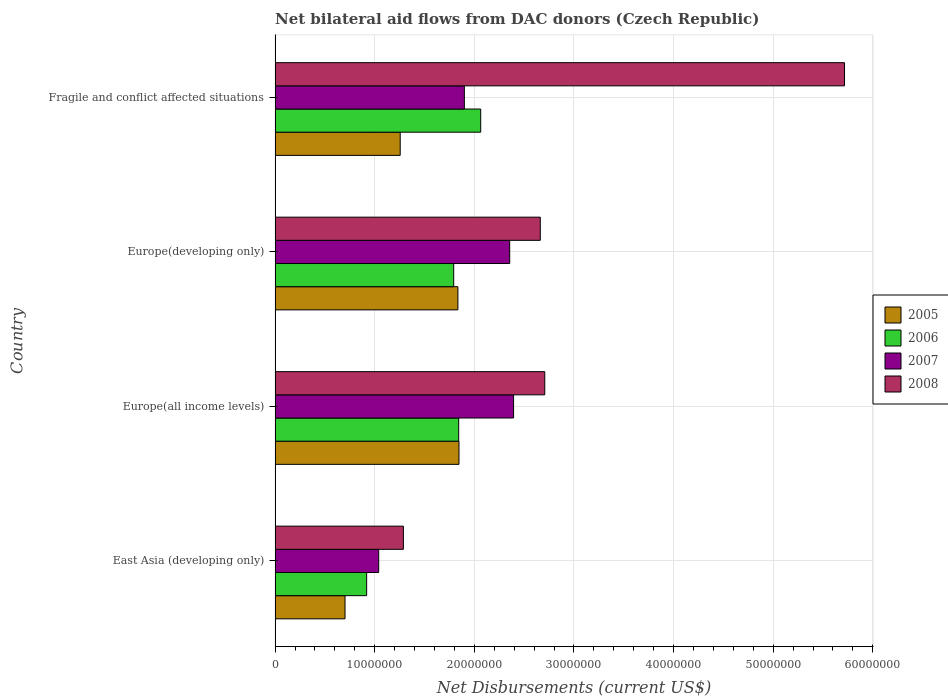Are the number of bars on each tick of the Y-axis equal?
Ensure brevity in your answer.  Yes. How many bars are there on the 4th tick from the top?
Make the answer very short. 4. How many bars are there on the 1st tick from the bottom?
Offer a very short reply. 4. What is the label of the 2nd group of bars from the top?
Provide a short and direct response. Europe(developing only). In how many cases, is the number of bars for a given country not equal to the number of legend labels?
Offer a very short reply. 0. What is the net bilateral aid flows in 2005 in East Asia (developing only)?
Offer a very short reply. 7.02e+06. Across all countries, what is the maximum net bilateral aid flows in 2005?
Make the answer very short. 1.85e+07. Across all countries, what is the minimum net bilateral aid flows in 2006?
Provide a succinct answer. 9.19e+06. In which country was the net bilateral aid flows in 2007 maximum?
Your answer should be very brief. Europe(all income levels). In which country was the net bilateral aid flows in 2008 minimum?
Make the answer very short. East Asia (developing only). What is the total net bilateral aid flows in 2007 in the graph?
Make the answer very short. 7.69e+07. What is the difference between the net bilateral aid flows in 2005 in East Asia (developing only) and that in Fragile and conflict affected situations?
Give a very brief answer. -5.54e+06. What is the difference between the net bilateral aid flows in 2008 in Europe(developing only) and the net bilateral aid flows in 2006 in Europe(all income levels)?
Your answer should be very brief. 8.19e+06. What is the average net bilateral aid flows in 2006 per country?
Make the answer very short. 1.65e+07. What is the difference between the net bilateral aid flows in 2008 and net bilateral aid flows in 2007 in Europe(developing only)?
Your response must be concise. 3.07e+06. What is the ratio of the net bilateral aid flows in 2008 in East Asia (developing only) to that in Fragile and conflict affected situations?
Make the answer very short. 0.23. Is the net bilateral aid flows in 2008 in East Asia (developing only) less than that in Europe(all income levels)?
Your response must be concise. Yes. Is the difference between the net bilateral aid flows in 2008 in East Asia (developing only) and Europe(all income levels) greater than the difference between the net bilateral aid flows in 2007 in East Asia (developing only) and Europe(all income levels)?
Give a very brief answer. No. What is the difference between the highest and the lowest net bilateral aid flows in 2006?
Your answer should be very brief. 1.14e+07. In how many countries, is the net bilateral aid flows in 2007 greater than the average net bilateral aid flows in 2007 taken over all countries?
Your answer should be very brief. 2. Is the sum of the net bilateral aid flows in 2007 in East Asia (developing only) and Fragile and conflict affected situations greater than the maximum net bilateral aid flows in 2006 across all countries?
Your response must be concise. Yes. What does the 3rd bar from the top in East Asia (developing only) represents?
Give a very brief answer. 2006. What does the 2nd bar from the bottom in Europe(developing only) represents?
Give a very brief answer. 2006. Does the graph contain grids?
Your answer should be compact. Yes. How are the legend labels stacked?
Your answer should be very brief. Vertical. What is the title of the graph?
Provide a short and direct response. Net bilateral aid flows from DAC donors (Czech Republic). What is the label or title of the X-axis?
Give a very brief answer. Net Disbursements (current US$). What is the Net Disbursements (current US$) of 2005 in East Asia (developing only)?
Your answer should be very brief. 7.02e+06. What is the Net Disbursements (current US$) of 2006 in East Asia (developing only)?
Give a very brief answer. 9.19e+06. What is the Net Disbursements (current US$) in 2007 in East Asia (developing only)?
Provide a succinct answer. 1.04e+07. What is the Net Disbursements (current US$) of 2008 in East Asia (developing only)?
Give a very brief answer. 1.29e+07. What is the Net Disbursements (current US$) in 2005 in Europe(all income levels)?
Your response must be concise. 1.85e+07. What is the Net Disbursements (current US$) of 2006 in Europe(all income levels)?
Offer a terse response. 1.84e+07. What is the Net Disbursements (current US$) of 2007 in Europe(all income levels)?
Your answer should be compact. 2.39e+07. What is the Net Disbursements (current US$) of 2008 in Europe(all income levels)?
Offer a very short reply. 2.71e+07. What is the Net Disbursements (current US$) in 2005 in Europe(developing only)?
Your response must be concise. 1.84e+07. What is the Net Disbursements (current US$) in 2006 in Europe(developing only)?
Your response must be concise. 1.79e+07. What is the Net Disbursements (current US$) in 2007 in Europe(developing only)?
Provide a succinct answer. 2.36e+07. What is the Net Disbursements (current US$) of 2008 in Europe(developing only)?
Offer a very short reply. 2.66e+07. What is the Net Disbursements (current US$) in 2005 in Fragile and conflict affected situations?
Offer a very short reply. 1.26e+07. What is the Net Disbursements (current US$) of 2006 in Fragile and conflict affected situations?
Offer a terse response. 2.06e+07. What is the Net Disbursements (current US$) in 2007 in Fragile and conflict affected situations?
Offer a terse response. 1.90e+07. What is the Net Disbursements (current US$) in 2008 in Fragile and conflict affected situations?
Give a very brief answer. 5.72e+07. Across all countries, what is the maximum Net Disbursements (current US$) in 2005?
Provide a succinct answer. 1.85e+07. Across all countries, what is the maximum Net Disbursements (current US$) in 2006?
Provide a succinct answer. 2.06e+07. Across all countries, what is the maximum Net Disbursements (current US$) of 2007?
Provide a succinct answer. 2.39e+07. Across all countries, what is the maximum Net Disbursements (current US$) in 2008?
Give a very brief answer. 5.72e+07. Across all countries, what is the minimum Net Disbursements (current US$) of 2005?
Ensure brevity in your answer.  7.02e+06. Across all countries, what is the minimum Net Disbursements (current US$) in 2006?
Give a very brief answer. 9.19e+06. Across all countries, what is the minimum Net Disbursements (current US$) of 2007?
Offer a very short reply. 1.04e+07. Across all countries, what is the minimum Net Disbursements (current US$) in 2008?
Provide a succinct answer. 1.29e+07. What is the total Net Disbursements (current US$) in 2005 in the graph?
Offer a terse response. 5.64e+07. What is the total Net Disbursements (current US$) of 2006 in the graph?
Make the answer very short. 6.62e+07. What is the total Net Disbursements (current US$) of 2007 in the graph?
Offer a terse response. 7.69e+07. What is the total Net Disbursements (current US$) of 2008 in the graph?
Offer a very short reply. 1.24e+08. What is the difference between the Net Disbursements (current US$) of 2005 in East Asia (developing only) and that in Europe(all income levels)?
Your answer should be compact. -1.14e+07. What is the difference between the Net Disbursements (current US$) of 2006 in East Asia (developing only) and that in Europe(all income levels)?
Offer a very short reply. -9.24e+06. What is the difference between the Net Disbursements (current US$) of 2007 in East Asia (developing only) and that in Europe(all income levels)?
Offer a very short reply. -1.35e+07. What is the difference between the Net Disbursements (current US$) of 2008 in East Asia (developing only) and that in Europe(all income levels)?
Your answer should be very brief. -1.42e+07. What is the difference between the Net Disbursements (current US$) in 2005 in East Asia (developing only) and that in Europe(developing only)?
Your answer should be very brief. -1.13e+07. What is the difference between the Net Disbursements (current US$) in 2006 in East Asia (developing only) and that in Europe(developing only)?
Provide a succinct answer. -8.74e+06. What is the difference between the Net Disbursements (current US$) in 2007 in East Asia (developing only) and that in Europe(developing only)?
Make the answer very short. -1.32e+07. What is the difference between the Net Disbursements (current US$) of 2008 in East Asia (developing only) and that in Europe(developing only)?
Offer a terse response. -1.37e+07. What is the difference between the Net Disbursements (current US$) of 2005 in East Asia (developing only) and that in Fragile and conflict affected situations?
Keep it short and to the point. -5.54e+06. What is the difference between the Net Disbursements (current US$) of 2006 in East Asia (developing only) and that in Fragile and conflict affected situations?
Offer a terse response. -1.14e+07. What is the difference between the Net Disbursements (current US$) in 2007 in East Asia (developing only) and that in Fragile and conflict affected situations?
Offer a terse response. -8.60e+06. What is the difference between the Net Disbursements (current US$) in 2008 in East Asia (developing only) and that in Fragile and conflict affected situations?
Make the answer very short. -4.43e+07. What is the difference between the Net Disbursements (current US$) in 2005 in Europe(all income levels) and that in Europe(developing only)?
Your response must be concise. 1.10e+05. What is the difference between the Net Disbursements (current US$) in 2006 in Europe(all income levels) and that in Europe(developing only)?
Your answer should be compact. 5.00e+05. What is the difference between the Net Disbursements (current US$) of 2007 in Europe(all income levels) and that in Europe(developing only)?
Make the answer very short. 3.90e+05. What is the difference between the Net Disbursements (current US$) in 2005 in Europe(all income levels) and that in Fragile and conflict affected situations?
Offer a very short reply. 5.90e+06. What is the difference between the Net Disbursements (current US$) of 2006 in Europe(all income levels) and that in Fragile and conflict affected situations?
Provide a succinct answer. -2.21e+06. What is the difference between the Net Disbursements (current US$) in 2007 in Europe(all income levels) and that in Fragile and conflict affected situations?
Give a very brief answer. 4.94e+06. What is the difference between the Net Disbursements (current US$) of 2008 in Europe(all income levels) and that in Fragile and conflict affected situations?
Make the answer very short. -3.01e+07. What is the difference between the Net Disbursements (current US$) in 2005 in Europe(developing only) and that in Fragile and conflict affected situations?
Keep it short and to the point. 5.79e+06. What is the difference between the Net Disbursements (current US$) in 2006 in Europe(developing only) and that in Fragile and conflict affected situations?
Your answer should be compact. -2.71e+06. What is the difference between the Net Disbursements (current US$) of 2007 in Europe(developing only) and that in Fragile and conflict affected situations?
Your answer should be compact. 4.55e+06. What is the difference between the Net Disbursements (current US$) in 2008 in Europe(developing only) and that in Fragile and conflict affected situations?
Your answer should be very brief. -3.05e+07. What is the difference between the Net Disbursements (current US$) of 2005 in East Asia (developing only) and the Net Disbursements (current US$) of 2006 in Europe(all income levels)?
Make the answer very short. -1.14e+07. What is the difference between the Net Disbursements (current US$) in 2005 in East Asia (developing only) and the Net Disbursements (current US$) in 2007 in Europe(all income levels)?
Ensure brevity in your answer.  -1.69e+07. What is the difference between the Net Disbursements (current US$) in 2005 in East Asia (developing only) and the Net Disbursements (current US$) in 2008 in Europe(all income levels)?
Your response must be concise. -2.00e+07. What is the difference between the Net Disbursements (current US$) in 2006 in East Asia (developing only) and the Net Disbursements (current US$) in 2007 in Europe(all income levels)?
Provide a short and direct response. -1.48e+07. What is the difference between the Net Disbursements (current US$) of 2006 in East Asia (developing only) and the Net Disbursements (current US$) of 2008 in Europe(all income levels)?
Provide a short and direct response. -1.79e+07. What is the difference between the Net Disbursements (current US$) in 2007 in East Asia (developing only) and the Net Disbursements (current US$) in 2008 in Europe(all income levels)?
Provide a short and direct response. -1.67e+07. What is the difference between the Net Disbursements (current US$) in 2005 in East Asia (developing only) and the Net Disbursements (current US$) in 2006 in Europe(developing only)?
Provide a short and direct response. -1.09e+07. What is the difference between the Net Disbursements (current US$) in 2005 in East Asia (developing only) and the Net Disbursements (current US$) in 2007 in Europe(developing only)?
Offer a terse response. -1.65e+07. What is the difference between the Net Disbursements (current US$) of 2005 in East Asia (developing only) and the Net Disbursements (current US$) of 2008 in Europe(developing only)?
Ensure brevity in your answer.  -1.96e+07. What is the difference between the Net Disbursements (current US$) in 2006 in East Asia (developing only) and the Net Disbursements (current US$) in 2007 in Europe(developing only)?
Provide a succinct answer. -1.44e+07. What is the difference between the Net Disbursements (current US$) in 2006 in East Asia (developing only) and the Net Disbursements (current US$) in 2008 in Europe(developing only)?
Offer a terse response. -1.74e+07. What is the difference between the Net Disbursements (current US$) in 2007 in East Asia (developing only) and the Net Disbursements (current US$) in 2008 in Europe(developing only)?
Offer a very short reply. -1.62e+07. What is the difference between the Net Disbursements (current US$) of 2005 in East Asia (developing only) and the Net Disbursements (current US$) of 2006 in Fragile and conflict affected situations?
Give a very brief answer. -1.36e+07. What is the difference between the Net Disbursements (current US$) of 2005 in East Asia (developing only) and the Net Disbursements (current US$) of 2007 in Fragile and conflict affected situations?
Offer a very short reply. -1.20e+07. What is the difference between the Net Disbursements (current US$) in 2005 in East Asia (developing only) and the Net Disbursements (current US$) in 2008 in Fragile and conflict affected situations?
Your answer should be very brief. -5.01e+07. What is the difference between the Net Disbursements (current US$) in 2006 in East Asia (developing only) and the Net Disbursements (current US$) in 2007 in Fragile and conflict affected situations?
Provide a succinct answer. -9.81e+06. What is the difference between the Net Disbursements (current US$) of 2006 in East Asia (developing only) and the Net Disbursements (current US$) of 2008 in Fragile and conflict affected situations?
Your answer should be compact. -4.80e+07. What is the difference between the Net Disbursements (current US$) in 2007 in East Asia (developing only) and the Net Disbursements (current US$) in 2008 in Fragile and conflict affected situations?
Your answer should be compact. -4.68e+07. What is the difference between the Net Disbursements (current US$) of 2005 in Europe(all income levels) and the Net Disbursements (current US$) of 2006 in Europe(developing only)?
Ensure brevity in your answer.  5.30e+05. What is the difference between the Net Disbursements (current US$) of 2005 in Europe(all income levels) and the Net Disbursements (current US$) of 2007 in Europe(developing only)?
Offer a very short reply. -5.09e+06. What is the difference between the Net Disbursements (current US$) of 2005 in Europe(all income levels) and the Net Disbursements (current US$) of 2008 in Europe(developing only)?
Offer a very short reply. -8.16e+06. What is the difference between the Net Disbursements (current US$) in 2006 in Europe(all income levels) and the Net Disbursements (current US$) in 2007 in Europe(developing only)?
Your answer should be very brief. -5.12e+06. What is the difference between the Net Disbursements (current US$) in 2006 in Europe(all income levels) and the Net Disbursements (current US$) in 2008 in Europe(developing only)?
Your response must be concise. -8.19e+06. What is the difference between the Net Disbursements (current US$) in 2007 in Europe(all income levels) and the Net Disbursements (current US$) in 2008 in Europe(developing only)?
Give a very brief answer. -2.68e+06. What is the difference between the Net Disbursements (current US$) in 2005 in Europe(all income levels) and the Net Disbursements (current US$) in 2006 in Fragile and conflict affected situations?
Your answer should be very brief. -2.18e+06. What is the difference between the Net Disbursements (current US$) of 2005 in Europe(all income levels) and the Net Disbursements (current US$) of 2007 in Fragile and conflict affected situations?
Offer a very short reply. -5.40e+05. What is the difference between the Net Disbursements (current US$) in 2005 in Europe(all income levels) and the Net Disbursements (current US$) in 2008 in Fragile and conflict affected situations?
Provide a short and direct response. -3.87e+07. What is the difference between the Net Disbursements (current US$) in 2006 in Europe(all income levels) and the Net Disbursements (current US$) in 2007 in Fragile and conflict affected situations?
Your response must be concise. -5.70e+05. What is the difference between the Net Disbursements (current US$) of 2006 in Europe(all income levels) and the Net Disbursements (current US$) of 2008 in Fragile and conflict affected situations?
Your answer should be compact. -3.87e+07. What is the difference between the Net Disbursements (current US$) in 2007 in Europe(all income levels) and the Net Disbursements (current US$) in 2008 in Fragile and conflict affected situations?
Offer a terse response. -3.32e+07. What is the difference between the Net Disbursements (current US$) in 2005 in Europe(developing only) and the Net Disbursements (current US$) in 2006 in Fragile and conflict affected situations?
Ensure brevity in your answer.  -2.29e+06. What is the difference between the Net Disbursements (current US$) of 2005 in Europe(developing only) and the Net Disbursements (current US$) of 2007 in Fragile and conflict affected situations?
Provide a short and direct response. -6.50e+05. What is the difference between the Net Disbursements (current US$) in 2005 in Europe(developing only) and the Net Disbursements (current US$) in 2008 in Fragile and conflict affected situations?
Give a very brief answer. -3.88e+07. What is the difference between the Net Disbursements (current US$) of 2006 in Europe(developing only) and the Net Disbursements (current US$) of 2007 in Fragile and conflict affected situations?
Your answer should be compact. -1.07e+06. What is the difference between the Net Disbursements (current US$) of 2006 in Europe(developing only) and the Net Disbursements (current US$) of 2008 in Fragile and conflict affected situations?
Offer a terse response. -3.92e+07. What is the difference between the Net Disbursements (current US$) of 2007 in Europe(developing only) and the Net Disbursements (current US$) of 2008 in Fragile and conflict affected situations?
Provide a short and direct response. -3.36e+07. What is the average Net Disbursements (current US$) in 2005 per country?
Provide a succinct answer. 1.41e+07. What is the average Net Disbursements (current US$) of 2006 per country?
Make the answer very short. 1.65e+07. What is the average Net Disbursements (current US$) in 2007 per country?
Provide a succinct answer. 1.92e+07. What is the average Net Disbursements (current US$) of 2008 per country?
Provide a short and direct response. 3.09e+07. What is the difference between the Net Disbursements (current US$) in 2005 and Net Disbursements (current US$) in 2006 in East Asia (developing only)?
Your answer should be very brief. -2.17e+06. What is the difference between the Net Disbursements (current US$) in 2005 and Net Disbursements (current US$) in 2007 in East Asia (developing only)?
Provide a succinct answer. -3.38e+06. What is the difference between the Net Disbursements (current US$) in 2005 and Net Disbursements (current US$) in 2008 in East Asia (developing only)?
Provide a succinct answer. -5.86e+06. What is the difference between the Net Disbursements (current US$) in 2006 and Net Disbursements (current US$) in 2007 in East Asia (developing only)?
Provide a succinct answer. -1.21e+06. What is the difference between the Net Disbursements (current US$) in 2006 and Net Disbursements (current US$) in 2008 in East Asia (developing only)?
Ensure brevity in your answer.  -3.69e+06. What is the difference between the Net Disbursements (current US$) of 2007 and Net Disbursements (current US$) of 2008 in East Asia (developing only)?
Provide a short and direct response. -2.48e+06. What is the difference between the Net Disbursements (current US$) of 2005 and Net Disbursements (current US$) of 2007 in Europe(all income levels)?
Your answer should be compact. -5.48e+06. What is the difference between the Net Disbursements (current US$) in 2005 and Net Disbursements (current US$) in 2008 in Europe(all income levels)?
Your answer should be compact. -8.61e+06. What is the difference between the Net Disbursements (current US$) in 2006 and Net Disbursements (current US$) in 2007 in Europe(all income levels)?
Offer a terse response. -5.51e+06. What is the difference between the Net Disbursements (current US$) in 2006 and Net Disbursements (current US$) in 2008 in Europe(all income levels)?
Keep it short and to the point. -8.64e+06. What is the difference between the Net Disbursements (current US$) of 2007 and Net Disbursements (current US$) of 2008 in Europe(all income levels)?
Make the answer very short. -3.13e+06. What is the difference between the Net Disbursements (current US$) in 2005 and Net Disbursements (current US$) in 2007 in Europe(developing only)?
Give a very brief answer. -5.20e+06. What is the difference between the Net Disbursements (current US$) of 2005 and Net Disbursements (current US$) of 2008 in Europe(developing only)?
Ensure brevity in your answer.  -8.27e+06. What is the difference between the Net Disbursements (current US$) of 2006 and Net Disbursements (current US$) of 2007 in Europe(developing only)?
Provide a succinct answer. -5.62e+06. What is the difference between the Net Disbursements (current US$) of 2006 and Net Disbursements (current US$) of 2008 in Europe(developing only)?
Provide a short and direct response. -8.69e+06. What is the difference between the Net Disbursements (current US$) in 2007 and Net Disbursements (current US$) in 2008 in Europe(developing only)?
Make the answer very short. -3.07e+06. What is the difference between the Net Disbursements (current US$) of 2005 and Net Disbursements (current US$) of 2006 in Fragile and conflict affected situations?
Give a very brief answer. -8.08e+06. What is the difference between the Net Disbursements (current US$) of 2005 and Net Disbursements (current US$) of 2007 in Fragile and conflict affected situations?
Ensure brevity in your answer.  -6.44e+06. What is the difference between the Net Disbursements (current US$) of 2005 and Net Disbursements (current US$) of 2008 in Fragile and conflict affected situations?
Offer a terse response. -4.46e+07. What is the difference between the Net Disbursements (current US$) of 2006 and Net Disbursements (current US$) of 2007 in Fragile and conflict affected situations?
Offer a very short reply. 1.64e+06. What is the difference between the Net Disbursements (current US$) in 2006 and Net Disbursements (current US$) in 2008 in Fragile and conflict affected situations?
Make the answer very short. -3.65e+07. What is the difference between the Net Disbursements (current US$) in 2007 and Net Disbursements (current US$) in 2008 in Fragile and conflict affected situations?
Ensure brevity in your answer.  -3.82e+07. What is the ratio of the Net Disbursements (current US$) in 2005 in East Asia (developing only) to that in Europe(all income levels)?
Your response must be concise. 0.38. What is the ratio of the Net Disbursements (current US$) in 2006 in East Asia (developing only) to that in Europe(all income levels)?
Offer a very short reply. 0.5. What is the ratio of the Net Disbursements (current US$) in 2007 in East Asia (developing only) to that in Europe(all income levels)?
Your answer should be compact. 0.43. What is the ratio of the Net Disbursements (current US$) of 2008 in East Asia (developing only) to that in Europe(all income levels)?
Provide a short and direct response. 0.48. What is the ratio of the Net Disbursements (current US$) of 2005 in East Asia (developing only) to that in Europe(developing only)?
Offer a terse response. 0.38. What is the ratio of the Net Disbursements (current US$) in 2006 in East Asia (developing only) to that in Europe(developing only)?
Provide a succinct answer. 0.51. What is the ratio of the Net Disbursements (current US$) in 2007 in East Asia (developing only) to that in Europe(developing only)?
Provide a short and direct response. 0.44. What is the ratio of the Net Disbursements (current US$) of 2008 in East Asia (developing only) to that in Europe(developing only)?
Offer a very short reply. 0.48. What is the ratio of the Net Disbursements (current US$) in 2005 in East Asia (developing only) to that in Fragile and conflict affected situations?
Ensure brevity in your answer.  0.56. What is the ratio of the Net Disbursements (current US$) in 2006 in East Asia (developing only) to that in Fragile and conflict affected situations?
Provide a succinct answer. 0.45. What is the ratio of the Net Disbursements (current US$) in 2007 in East Asia (developing only) to that in Fragile and conflict affected situations?
Offer a terse response. 0.55. What is the ratio of the Net Disbursements (current US$) of 2008 in East Asia (developing only) to that in Fragile and conflict affected situations?
Keep it short and to the point. 0.23. What is the ratio of the Net Disbursements (current US$) in 2006 in Europe(all income levels) to that in Europe(developing only)?
Provide a short and direct response. 1.03. What is the ratio of the Net Disbursements (current US$) of 2007 in Europe(all income levels) to that in Europe(developing only)?
Provide a succinct answer. 1.02. What is the ratio of the Net Disbursements (current US$) in 2008 in Europe(all income levels) to that in Europe(developing only)?
Your answer should be compact. 1.02. What is the ratio of the Net Disbursements (current US$) of 2005 in Europe(all income levels) to that in Fragile and conflict affected situations?
Provide a short and direct response. 1.47. What is the ratio of the Net Disbursements (current US$) of 2006 in Europe(all income levels) to that in Fragile and conflict affected situations?
Offer a very short reply. 0.89. What is the ratio of the Net Disbursements (current US$) in 2007 in Europe(all income levels) to that in Fragile and conflict affected situations?
Make the answer very short. 1.26. What is the ratio of the Net Disbursements (current US$) in 2008 in Europe(all income levels) to that in Fragile and conflict affected situations?
Your answer should be very brief. 0.47. What is the ratio of the Net Disbursements (current US$) in 2005 in Europe(developing only) to that in Fragile and conflict affected situations?
Keep it short and to the point. 1.46. What is the ratio of the Net Disbursements (current US$) of 2006 in Europe(developing only) to that in Fragile and conflict affected situations?
Make the answer very short. 0.87. What is the ratio of the Net Disbursements (current US$) of 2007 in Europe(developing only) to that in Fragile and conflict affected situations?
Give a very brief answer. 1.24. What is the ratio of the Net Disbursements (current US$) of 2008 in Europe(developing only) to that in Fragile and conflict affected situations?
Keep it short and to the point. 0.47. What is the difference between the highest and the second highest Net Disbursements (current US$) in 2005?
Your answer should be very brief. 1.10e+05. What is the difference between the highest and the second highest Net Disbursements (current US$) of 2006?
Provide a succinct answer. 2.21e+06. What is the difference between the highest and the second highest Net Disbursements (current US$) in 2008?
Provide a succinct answer. 3.01e+07. What is the difference between the highest and the lowest Net Disbursements (current US$) of 2005?
Your answer should be very brief. 1.14e+07. What is the difference between the highest and the lowest Net Disbursements (current US$) of 2006?
Your answer should be very brief. 1.14e+07. What is the difference between the highest and the lowest Net Disbursements (current US$) of 2007?
Offer a terse response. 1.35e+07. What is the difference between the highest and the lowest Net Disbursements (current US$) of 2008?
Offer a very short reply. 4.43e+07. 